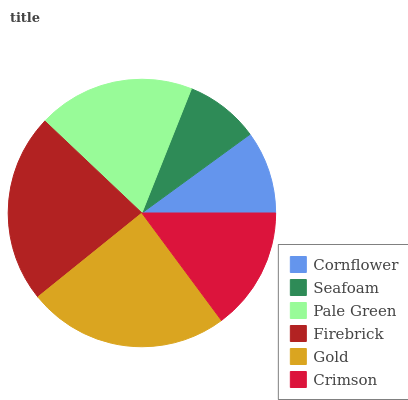Is Seafoam the minimum?
Answer yes or no. Yes. Is Gold the maximum?
Answer yes or no. Yes. Is Pale Green the minimum?
Answer yes or no. No. Is Pale Green the maximum?
Answer yes or no. No. Is Pale Green greater than Seafoam?
Answer yes or no. Yes. Is Seafoam less than Pale Green?
Answer yes or no. Yes. Is Seafoam greater than Pale Green?
Answer yes or no. No. Is Pale Green less than Seafoam?
Answer yes or no. No. Is Pale Green the high median?
Answer yes or no. Yes. Is Crimson the low median?
Answer yes or no. Yes. Is Seafoam the high median?
Answer yes or no. No. Is Cornflower the low median?
Answer yes or no. No. 